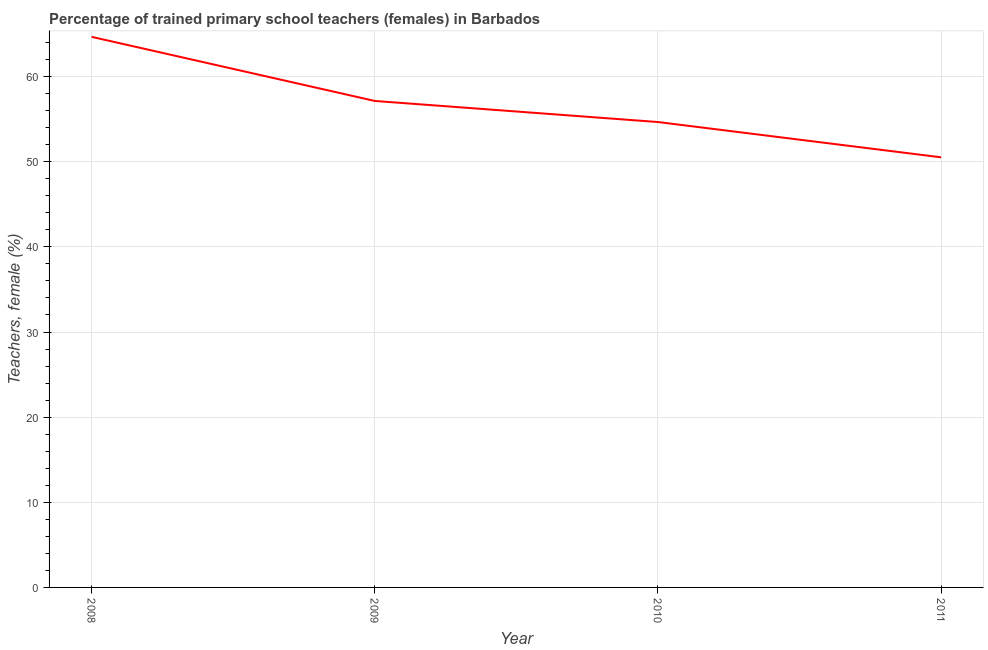What is the percentage of trained female teachers in 2009?
Your answer should be very brief. 57.14. Across all years, what is the maximum percentage of trained female teachers?
Your answer should be very brief. 64.67. Across all years, what is the minimum percentage of trained female teachers?
Ensure brevity in your answer.  50.52. What is the sum of the percentage of trained female teachers?
Your answer should be compact. 227.01. What is the difference between the percentage of trained female teachers in 2009 and 2011?
Your answer should be compact. 6.62. What is the average percentage of trained female teachers per year?
Your answer should be very brief. 56.75. What is the median percentage of trained female teachers?
Your response must be concise. 55.9. Do a majority of the years between 2009 and 2008 (inclusive) have percentage of trained female teachers greater than 20 %?
Offer a very short reply. No. What is the ratio of the percentage of trained female teachers in 2008 to that in 2009?
Keep it short and to the point. 1.13. What is the difference between the highest and the second highest percentage of trained female teachers?
Offer a very short reply. 7.53. What is the difference between the highest and the lowest percentage of trained female teachers?
Your response must be concise. 14.15. Does the percentage of trained female teachers monotonically increase over the years?
Provide a short and direct response. No. How many years are there in the graph?
Keep it short and to the point. 4. What is the difference between two consecutive major ticks on the Y-axis?
Offer a very short reply. 10. Are the values on the major ticks of Y-axis written in scientific E-notation?
Your answer should be very brief. No. Does the graph contain grids?
Your answer should be compact. Yes. What is the title of the graph?
Your answer should be compact. Percentage of trained primary school teachers (females) in Barbados. What is the label or title of the X-axis?
Your answer should be compact. Year. What is the label or title of the Y-axis?
Offer a terse response. Teachers, female (%). What is the Teachers, female (%) of 2008?
Your answer should be compact. 64.67. What is the Teachers, female (%) of 2009?
Give a very brief answer. 57.14. What is the Teachers, female (%) of 2010?
Provide a short and direct response. 54.67. What is the Teachers, female (%) of 2011?
Your answer should be very brief. 50.52. What is the difference between the Teachers, female (%) in 2008 and 2009?
Make the answer very short. 7.53. What is the difference between the Teachers, female (%) in 2008 and 2010?
Your answer should be very brief. 10.01. What is the difference between the Teachers, female (%) in 2008 and 2011?
Offer a terse response. 14.15. What is the difference between the Teachers, female (%) in 2009 and 2010?
Your answer should be compact. 2.48. What is the difference between the Teachers, female (%) in 2009 and 2011?
Offer a very short reply. 6.62. What is the difference between the Teachers, female (%) in 2010 and 2011?
Your answer should be very brief. 4.14. What is the ratio of the Teachers, female (%) in 2008 to that in 2009?
Offer a very short reply. 1.13. What is the ratio of the Teachers, female (%) in 2008 to that in 2010?
Offer a terse response. 1.18. What is the ratio of the Teachers, female (%) in 2008 to that in 2011?
Your answer should be very brief. 1.28. What is the ratio of the Teachers, female (%) in 2009 to that in 2010?
Your answer should be very brief. 1.04. What is the ratio of the Teachers, female (%) in 2009 to that in 2011?
Keep it short and to the point. 1.13. What is the ratio of the Teachers, female (%) in 2010 to that in 2011?
Keep it short and to the point. 1.08. 